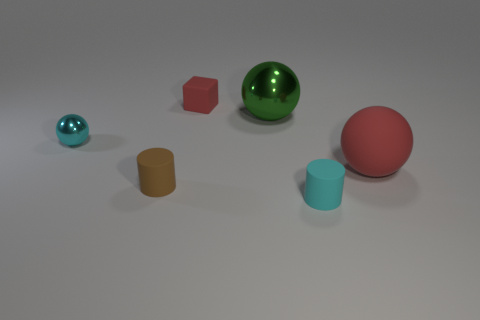There is a small cyan thing that is the same material as the large green sphere; what shape is it? The small cyan object shares the same smooth, shiny material with the large green sphere, indicating that they are both likely made of a similar substance, perhaps a polished plastic or metallic finish. As for its shape, the cyan object is a smaller sphere. 